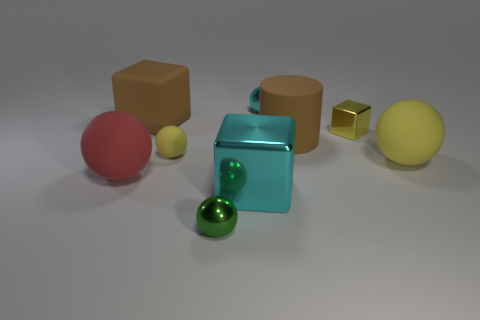Subtract 1 spheres. How many spheres are left? 4 Subtract all red spheres. How many spheres are left? 4 Subtract all large red spheres. How many spheres are left? 4 Subtract all brown balls. Subtract all gray cubes. How many balls are left? 5 Add 1 big cyan shiny things. How many objects exist? 10 Subtract all cylinders. How many objects are left? 8 Add 9 big purple things. How many big purple things exist? 9 Subtract 0 cyan cylinders. How many objects are left? 9 Subtract all tiny yellow shiny balls. Subtract all tiny matte balls. How many objects are left? 8 Add 1 large yellow rubber balls. How many large yellow rubber balls are left? 2 